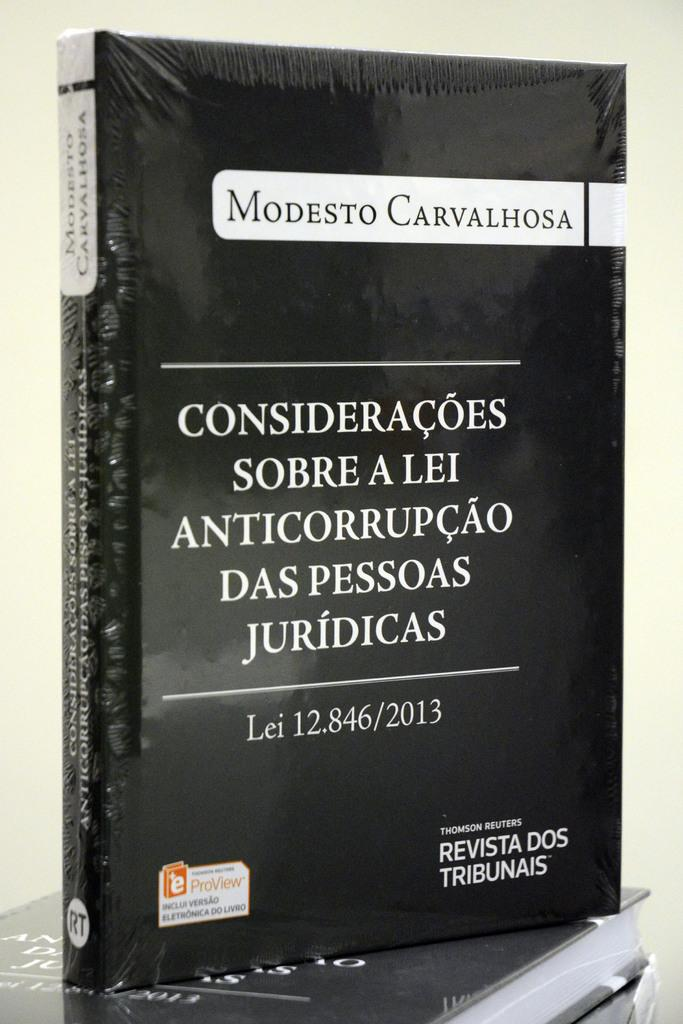<image>
Summarize the visual content of the image. A book with a black background is authored by Modesto Carvalhosa. 